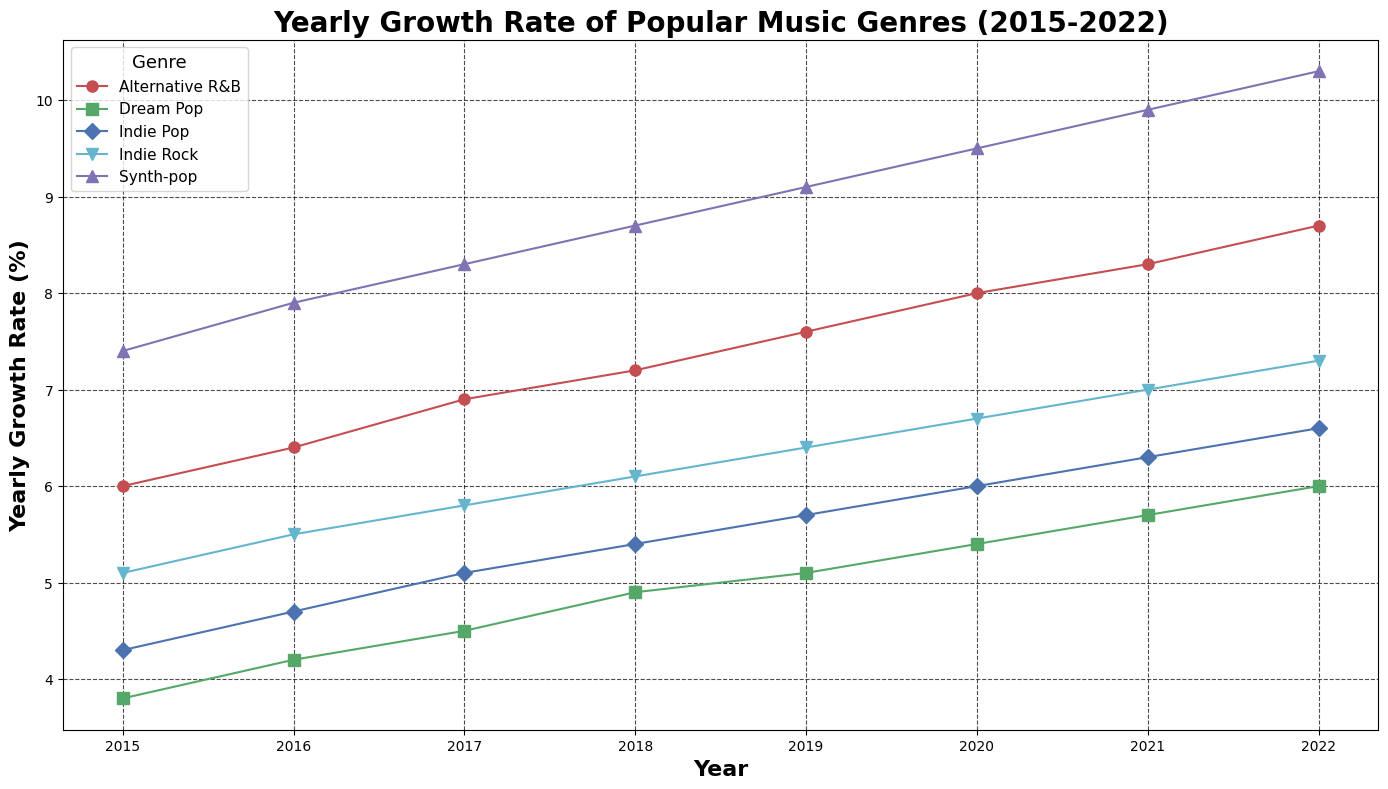What's the general trend for Synth-pop from 2015 to 2022? To determine the trend, observe the yearly growth rate for Synth-pop over the years on the plot. The line's slope indicates a continuous increase in growth rate over time.
Answer: Increasing Which genre had the highest growth rate in 2017? Look for the highest point among the markers on the 2017 vertical line. The genre with the highest marker is Synth-pop.
Answer: Synth-pop In which year did Dream Pop have a growth rate equal to or higher than 5%? Identify points on the Dream Pop line that are at or above the 5% mark. This is seen in 2018, 2019, 2020, 2021, and 2022.
Answer: 2018, 2019, 2020, 2021, 2022 Between 2015 and 2020, which genre had the smallest average yearly growth rate? Calculate the average yearly growth rate for each genre between 2015 and 2020 by summing their values and dividing by the number of years. Dream Pop's average turns out to be the smallest.
Answer: Dream Pop In what year did Alternative R&B surpass 8% growth rate? Find where the marker for Alternative R&B crosses the 8% line. This occurs in 2020.
Answer: 2020 How does the growth rate of Indie Rock in 2020 compare to its rate in 2015? Identify the points for Indie Rock in both 2020 and 2015 and compare the values. The growth rate in 2020 is higher than in 2015.
Answer: Higher What is the difference in growth rate between Indie Pop and Synth-pop in 2022? Subtract the growth rate of Indie Pop from Synth-pop in 2022. The difference is 10.3% - 6.6% = 3.7%.
Answer: 3.7% Which genre showed the most consistent growth (least fluctuation) from 2015 to 2022? Assess the lines' smoothness and consistency in growth; check for genres with minimal changes year to year. Indie Pop shows the least fluctuation.
Answer: Indie Pop Compare the yearly growth rates of Synth-pop and Alternative R&B in 2021. Which one had a higher value? Look at the markers for 2021 of both genres. Synth-pop has a higher value at 9.9% compared to Alternative R&B's 8.3%.
Answer: Synth-pop 